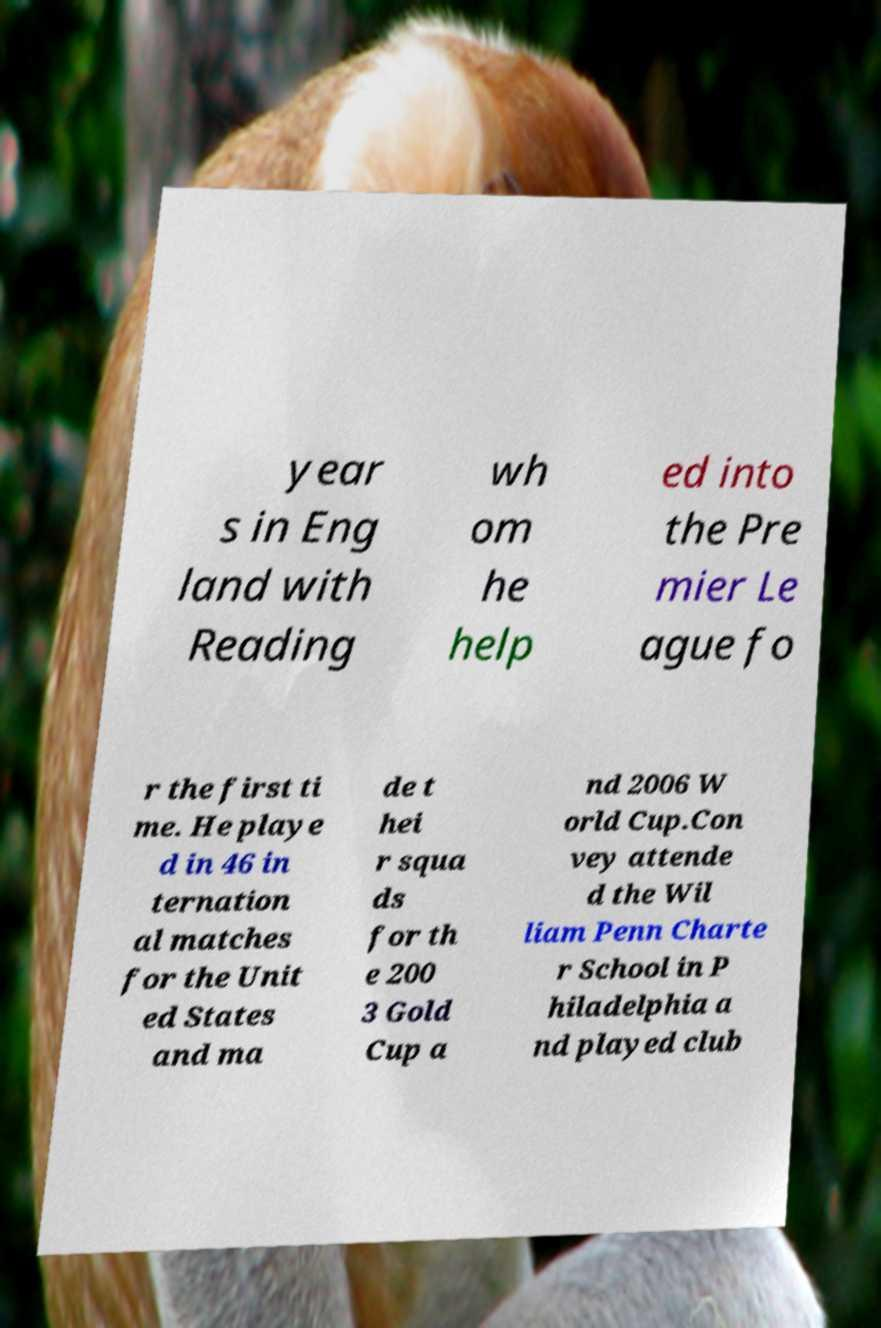Please identify and transcribe the text found in this image. year s in Eng land with Reading wh om he help ed into the Pre mier Le ague fo r the first ti me. He playe d in 46 in ternation al matches for the Unit ed States and ma de t hei r squa ds for th e 200 3 Gold Cup a nd 2006 W orld Cup.Con vey attende d the Wil liam Penn Charte r School in P hiladelphia a nd played club 